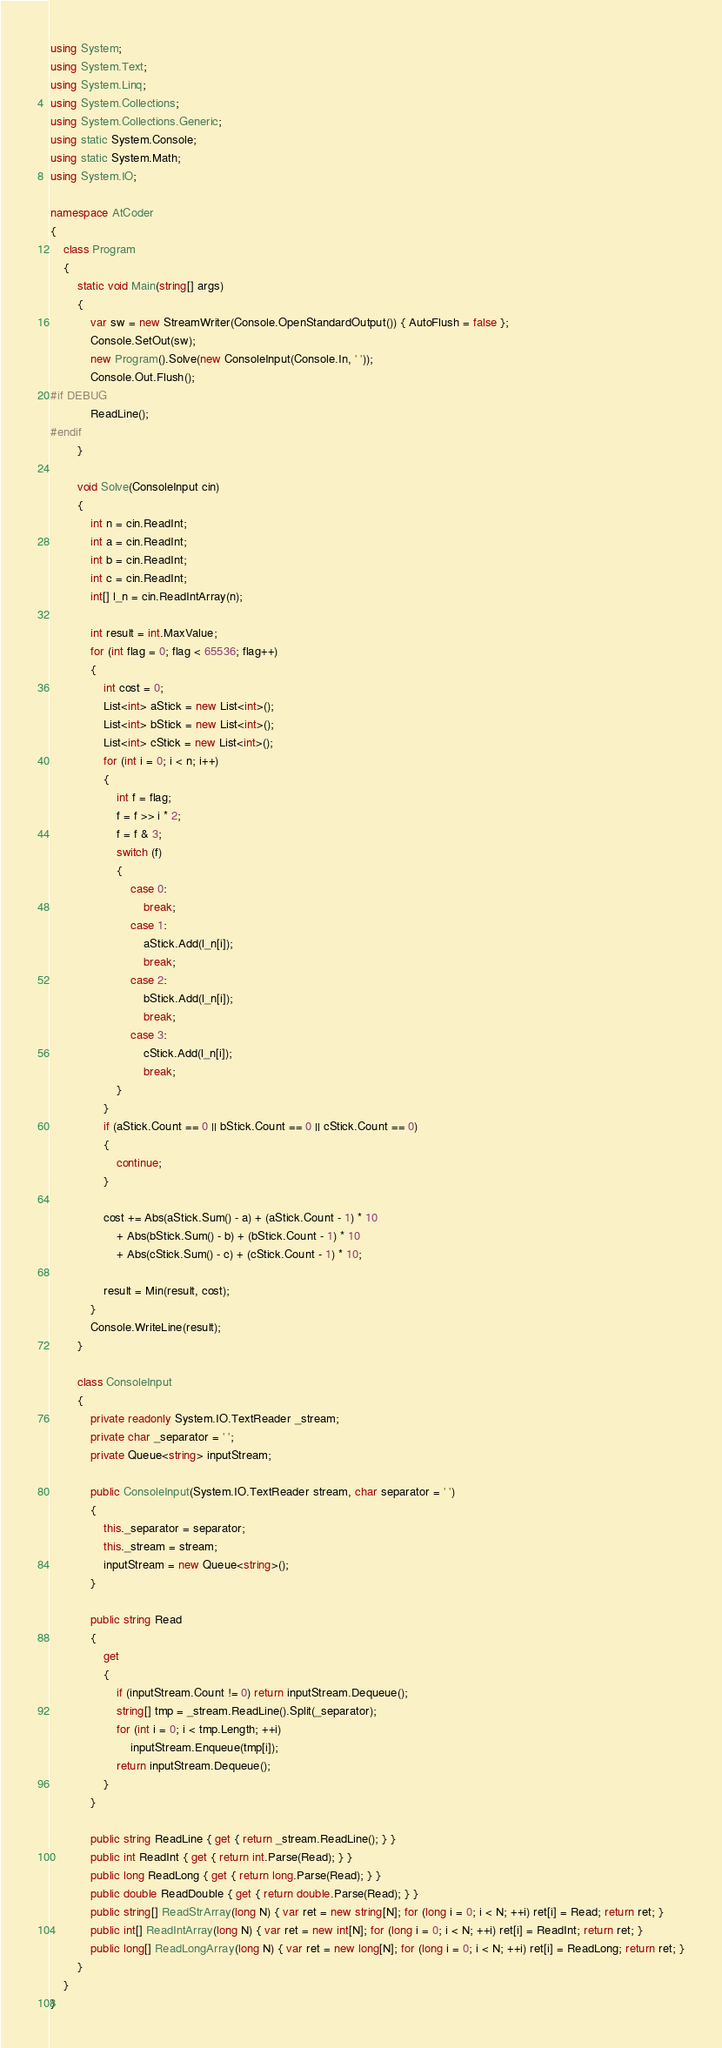Convert code to text. <code><loc_0><loc_0><loc_500><loc_500><_C#_>using System;
using System.Text;
using System.Linq;
using System.Collections;
using System.Collections.Generic;
using static System.Console;
using static System.Math;
using System.IO;

namespace AtCoder
{
    class Program
    {
        static void Main(string[] args)
        {
            var sw = new StreamWriter(Console.OpenStandardOutput()) { AutoFlush = false };
            Console.SetOut(sw);
            new Program().Solve(new ConsoleInput(Console.In, ' '));
            Console.Out.Flush();
#if DEBUG
            ReadLine();
#endif
        }

        void Solve(ConsoleInput cin)
        {
            int n = cin.ReadInt;
            int a = cin.ReadInt;
            int b = cin.ReadInt;
            int c = cin.ReadInt;
            int[] l_n = cin.ReadIntArray(n);

            int result = int.MaxValue;
            for (int flag = 0; flag < 65536; flag++)
            {
                int cost = 0;
                List<int> aStick = new List<int>();
                List<int> bStick = new List<int>();
                List<int> cStick = new List<int>();
                for (int i = 0; i < n; i++)
                {
                    int f = flag;
                    f = f >> i * 2;
                    f = f & 3;
                    switch (f)
                    {
                        case 0:
                            break;
                        case 1:
                            aStick.Add(l_n[i]);
                            break;
                        case 2:
                            bStick.Add(l_n[i]);
                            break;
                        case 3:
                            cStick.Add(l_n[i]);
                            break;
                    }
                }
                if (aStick.Count == 0 || bStick.Count == 0 || cStick.Count == 0)
                {
                    continue;
                }

                cost += Abs(aStick.Sum() - a) + (aStick.Count - 1) * 10
                    + Abs(bStick.Sum() - b) + (bStick.Count - 1) * 10
                    + Abs(cStick.Sum() - c) + (cStick.Count - 1) * 10;

                result = Min(result, cost);
            }
            Console.WriteLine(result);
        }

        class ConsoleInput
        {
            private readonly System.IO.TextReader _stream;
            private char _separator = ' ';
            private Queue<string> inputStream;

            public ConsoleInput(System.IO.TextReader stream, char separator = ' ')
            {
                this._separator = separator;
                this._stream = stream;
                inputStream = new Queue<string>();
            }

            public string Read
            {
                get
                {
                    if (inputStream.Count != 0) return inputStream.Dequeue();
                    string[] tmp = _stream.ReadLine().Split(_separator);
                    for (int i = 0; i < tmp.Length; ++i)
                        inputStream.Enqueue(tmp[i]);
                    return inputStream.Dequeue();
                }
            }

            public string ReadLine { get { return _stream.ReadLine(); } }
            public int ReadInt { get { return int.Parse(Read); } }
            public long ReadLong { get { return long.Parse(Read); } }
            public double ReadDouble { get { return double.Parse(Read); } }
            public string[] ReadStrArray(long N) { var ret = new string[N]; for (long i = 0; i < N; ++i) ret[i] = Read; return ret; }
            public int[] ReadIntArray(long N) { var ret = new int[N]; for (long i = 0; i < N; ++i) ret[i] = ReadInt; return ret; }
            public long[] ReadLongArray(long N) { var ret = new long[N]; for (long i = 0; i < N; ++i) ret[i] = ReadLong; return ret; }
        }
    }
}</code> 